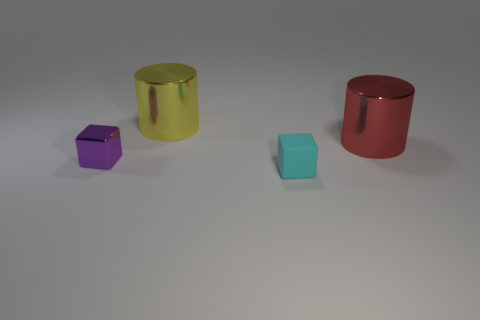What is the material of the other small thing that is the same shape as the small cyan object?
Ensure brevity in your answer.  Metal. What size is the metallic object on the right side of the tiny thing that is in front of the purple metallic object?
Make the answer very short. Large. There is a large object behind the big red cylinder; what is its material?
Offer a terse response. Metal. The other cylinder that is the same material as the red cylinder is what size?
Provide a succinct answer. Large. How many other small objects have the same shape as the rubber object?
Keep it short and to the point. 1. There is a yellow shiny thing; does it have the same shape as the small object that is right of the small purple object?
Give a very brief answer. No. Is there another object made of the same material as the small cyan object?
Offer a terse response. No. Is there any other thing that is the same material as the tiny purple cube?
Offer a very short reply. Yes. There is a small block on the right side of the big metallic thing that is on the left side of the cyan block; what is its material?
Offer a terse response. Rubber. There is a cylinder that is on the right side of the cyan object that is in front of the shiny object behind the large red shiny cylinder; what is its size?
Provide a short and direct response. Large. 